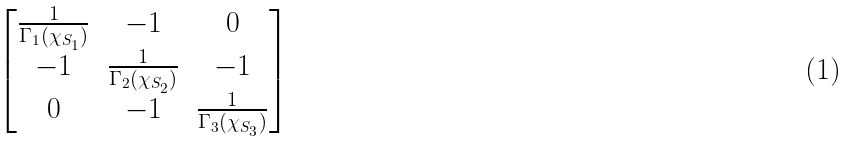<formula> <loc_0><loc_0><loc_500><loc_500>\begin{bmatrix} \frac { 1 } { \Gamma _ { 1 } ( \chi _ { S _ { 1 } } ) } & - 1 & 0 \\ - 1 & \frac { 1 } { \Gamma _ { 2 } ( \chi _ { S _ { 2 } } ) } & - 1 \\ 0 & - 1 & \frac { 1 } { \Gamma _ { 3 } ( \chi _ { S _ { 3 } } ) } \end{bmatrix}</formula> 